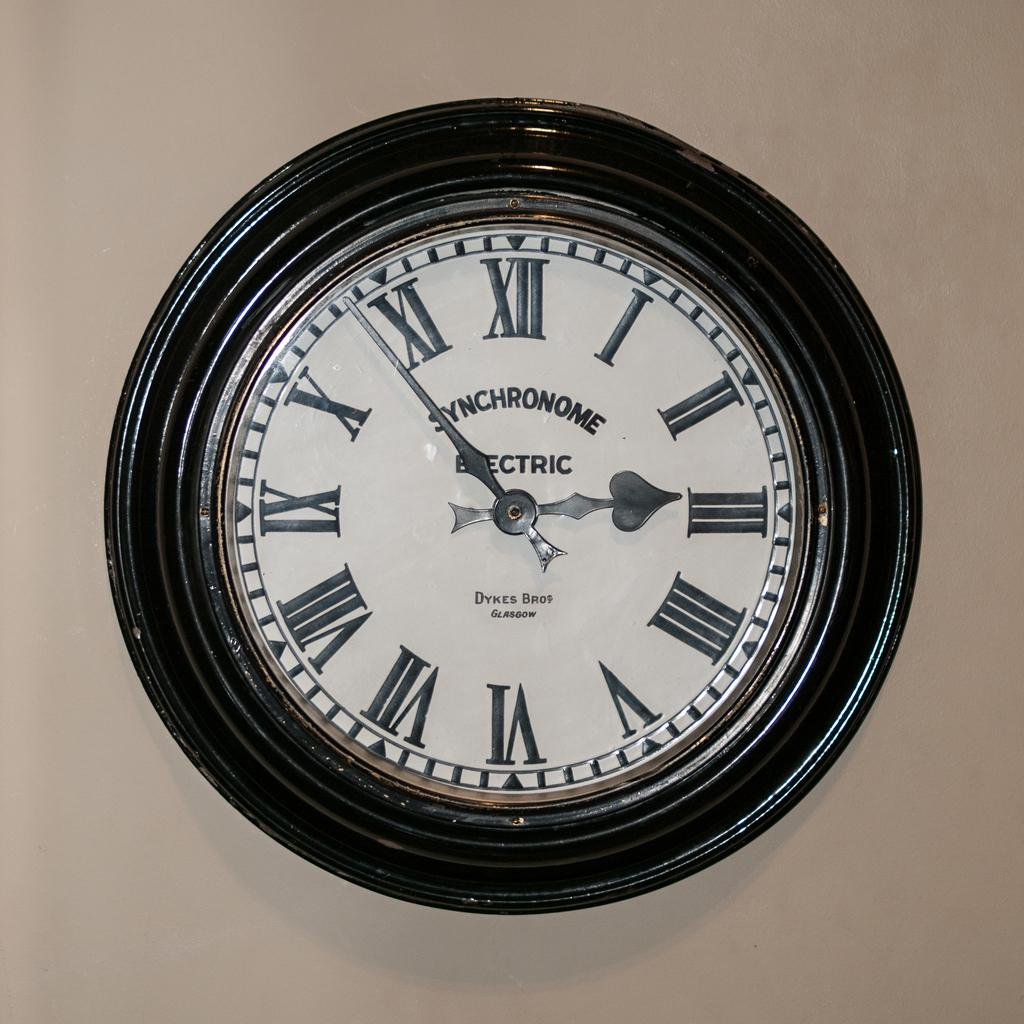Provide a one-sentence caption for the provided image. A wall mounted electric clock has Roman numerals on its face. 